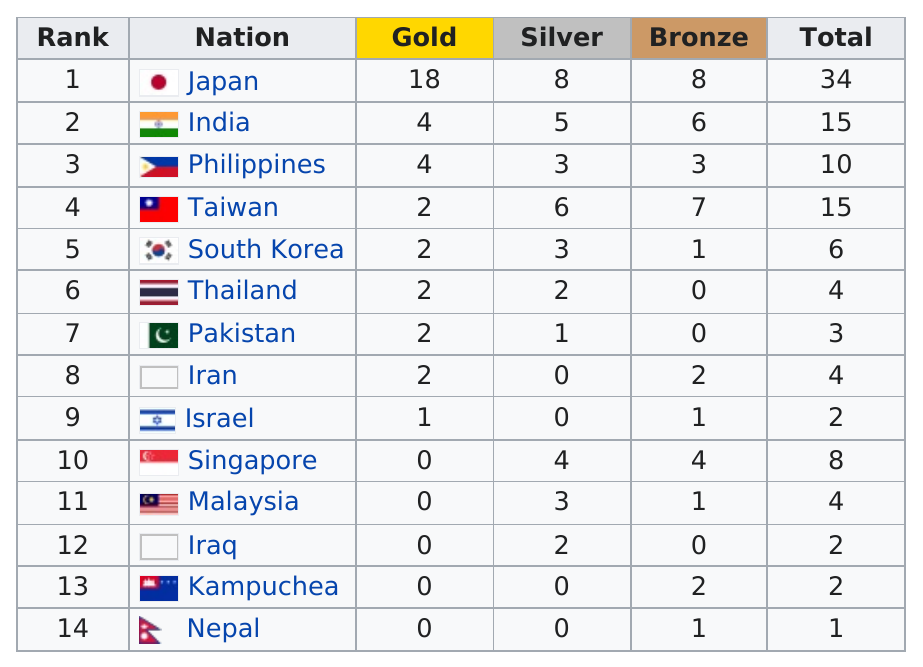Draw attention to some important aspects in this diagram. Four nations have won only one bronze medal. Nepal is the country that has won only one overall medal in the history of the Olympic Games. Japan is the top gold medal earner. The total number of silver awards given is 37. A total of 37 gold medals were awarded. 